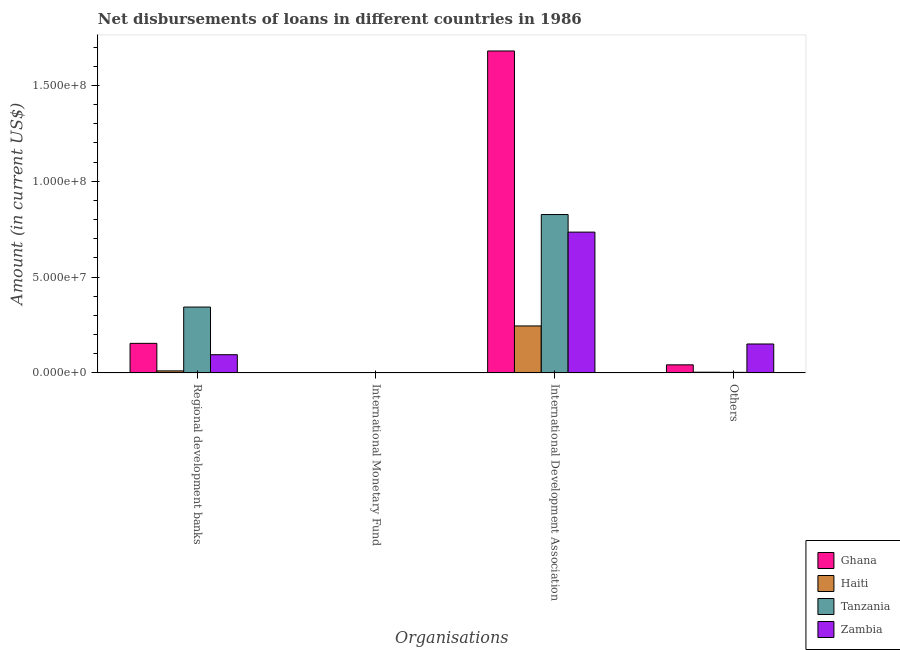How many different coloured bars are there?
Your answer should be compact. 4. Are the number of bars on each tick of the X-axis equal?
Offer a terse response. No. What is the label of the 1st group of bars from the left?
Provide a short and direct response. Regional development banks. What is the amount of loan disimbursed by other organisations in Tanzania?
Keep it short and to the point. 2.67e+05. Across all countries, what is the maximum amount of loan disimbursed by other organisations?
Keep it short and to the point. 1.51e+07. Across all countries, what is the minimum amount of loan disimbursed by other organisations?
Your answer should be compact. 2.67e+05. What is the total amount of loan disimbursed by other organisations in the graph?
Make the answer very short. 1.99e+07. What is the difference between the amount of loan disimbursed by other organisations in Haiti and that in Ghana?
Offer a terse response. -3.83e+06. What is the difference between the amount of loan disimbursed by international monetary fund in Haiti and the amount of loan disimbursed by other organisations in Ghana?
Your answer should be very brief. -4.19e+06. What is the average amount of loan disimbursed by regional development banks per country?
Your answer should be very brief. 1.51e+07. What is the difference between the amount of loan disimbursed by international development association and amount of loan disimbursed by other organisations in Zambia?
Give a very brief answer. 5.84e+07. What is the ratio of the amount of loan disimbursed by international development association in Zambia to that in Tanzania?
Your answer should be compact. 0.89. What is the difference between the highest and the second highest amount of loan disimbursed by international development association?
Offer a very short reply. 8.53e+07. What is the difference between the highest and the lowest amount of loan disimbursed by other organisations?
Provide a short and direct response. 1.48e+07. What is the difference between two consecutive major ticks on the Y-axis?
Offer a terse response. 5.00e+07. Are the values on the major ticks of Y-axis written in scientific E-notation?
Ensure brevity in your answer.  Yes. Does the graph contain grids?
Your response must be concise. No. Where does the legend appear in the graph?
Give a very brief answer. Bottom right. What is the title of the graph?
Give a very brief answer. Net disbursements of loans in different countries in 1986. What is the label or title of the X-axis?
Provide a short and direct response. Organisations. What is the Amount (in current US$) of Ghana in Regional development banks?
Your answer should be compact. 1.54e+07. What is the Amount (in current US$) of Haiti in Regional development banks?
Your answer should be very brief. 1.03e+06. What is the Amount (in current US$) of Tanzania in Regional development banks?
Provide a succinct answer. 3.43e+07. What is the Amount (in current US$) of Zambia in Regional development banks?
Keep it short and to the point. 9.48e+06. What is the Amount (in current US$) of Ghana in International Development Association?
Offer a very short reply. 1.68e+08. What is the Amount (in current US$) of Haiti in International Development Association?
Your response must be concise. 2.45e+07. What is the Amount (in current US$) of Tanzania in International Development Association?
Make the answer very short. 8.26e+07. What is the Amount (in current US$) in Zambia in International Development Association?
Give a very brief answer. 7.34e+07. What is the Amount (in current US$) in Ghana in Others?
Offer a very short reply. 4.19e+06. What is the Amount (in current US$) in Haiti in Others?
Your answer should be compact. 3.60e+05. What is the Amount (in current US$) in Tanzania in Others?
Keep it short and to the point. 2.67e+05. What is the Amount (in current US$) of Zambia in Others?
Your answer should be compact. 1.51e+07. Across all Organisations, what is the maximum Amount (in current US$) in Ghana?
Provide a short and direct response. 1.68e+08. Across all Organisations, what is the maximum Amount (in current US$) in Haiti?
Provide a succinct answer. 2.45e+07. Across all Organisations, what is the maximum Amount (in current US$) of Tanzania?
Offer a terse response. 8.26e+07. Across all Organisations, what is the maximum Amount (in current US$) in Zambia?
Make the answer very short. 7.34e+07. Across all Organisations, what is the minimum Amount (in current US$) in Haiti?
Your response must be concise. 0. What is the total Amount (in current US$) of Ghana in the graph?
Offer a terse response. 1.88e+08. What is the total Amount (in current US$) of Haiti in the graph?
Provide a short and direct response. 2.59e+07. What is the total Amount (in current US$) in Tanzania in the graph?
Your answer should be very brief. 1.17e+08. What is the total Amount (in current US$) of Zambia in the graph?
Provide a short and direct response. 9.80e+07. What is the difference between the Amount (in current US$) of Ghana in Regional development banks and that in International Development Association?
Your answer should be compact. -1.53e+08. What is the difference between the Amount (in current US$) of Haiti in Regional development banks and that in International Development Association?
Your answer should be very brief. -2.35e+07. What is the difference between the Amount (in current US$) of Tanzania in Regional development banks and that in International Development Association?
Provide a short and direct response. -4.83e+07. What is the difference between the Amount (in current US$) in Zambia in Regional development banks and that in International Development Association?
Offer a very short reply. -6.40e+07. What is the difference between the Amount (in current US$) in Ghana in Regional development banks and that in Others?
Make the answer very short. 1.12e+07. What is the difference between the Amount (in current US$) in Haiti in Regional development banks and that in Others?
Ensure brevity in your answer.  6.70e+05. What is the difference between the Amount (in current US$) in Tanzania in Regional development banks and that in Others?
Provide a succinct answer. 3.41e+07. What is the difference between the Amount (in current US$) in Zambia in Regional development banks and that in Others?
Make the answer very short. -5.59e+06. What is the difference between the Amount (in current US$) of Ghana in International Development Association and that in Others?
Your answer should be compact. 1.64e+08. What is the difference between the Amount (in current US$) in Haiti in International Development Association and that in Others?
Your answer should be compact. 2.41e+07. What is the difference between the Amount (in current US$) of Tanzania in International Development Association and that in Others?
Provide a succinct answer. 8.23e+07. What is the difference between the Amount (in current US$) in Zambia in International Development Association and that in Others?
Keep it short and to the point. 5.84e+07. What is the difference between the Amount (in current US$) in Ghana in Regional development banks and the Amount (in current US$) in Haiti in International Development Association?
Provide a succinct answer. -9.08e+06. What is the difference between the Amount (in current US$) of Ghana in Regional development banks and the Amount (in current US$) of Tanzania in International Development Association?
Ensure brevity in your answer.  -6.72e+07. What is the difference between the Amount (in current US$) in Ghana in Regional development banks and the Amount (in current US$) in Zambia in International Development Association?
Your answer should be compact. -5.80e+07. What is the difference between the Amount (in current US$) of Haiti in Regional development banks and the Amount (in current US$) of Tanzania in International Development Association?
Keep it short and to the point. -8.16e+07. What is the difference between the Amount (in current US$) of Haiti in Regional development banks and the Amount (in current US$) of Zambia in International Development Association?
Your answer should be very brief. -7.24e+07. What is the difference between the Amount (in current US$) in Tanzania in Regional development banks and the Amount (in current US$) in Zambia in International Development Association?
Keep it short and to the point. -3.91e+07. What is the difference between the Amount (in current US$) in Ghana in Regional development banks and the Amount (in current US$) in Haiti in Others?
Your answer should be very brief. 1.50e+07. What is the difference between the Amount (in current US$) in Ghana in Regional development banks and the Amount (in current US$) in Tanzania in Others?
Offer a terse response. 1.51e+07. What is the difference between the Amount (in current US$) in Ghana in Regional development banks and the Amount (in current US$) in Zambia in Others?
Your answer should be compact. 3.32e+05. What is the difference between the Amount (in current US$) in Haiti in Regional development banks and the Amount (in current US$) in Tanzania in Others?
Keep it short and to the point. 7.63e+05. What is the difference between the Amount (in current US$) of Haiti in Regional development banks and the Amount (in current US$) of Zambia in Others?
Your answer should be compact. -1.40e+07. What is the difference between the Amount (in current US$) in Tanzania in Regional development banks and the Amount (in current US$) in Zambia in Others?
Ensure brevity in your answer.  1.93e+07. What is the difference between the Amount (in current US$) of Ghana in International Development Association and the Amount (in current US$) of Haiti in Others?
Offer a terse response. 1.68e+08. What is the difference between the Amount (in current US$) in Ghana in International Development Association and the Amount (in current US$) in Tanzania in Others?
Provide a short and direct response. 1.68e+08. What is the difference between the Amount (in current US$) in Ghana in International Development Association and the Amount (in current US$) in Zambia in Others?
Ensure brevity in your answer.  1.53e+08. What is the difference between the Amount (in current US$) of Haiti in International Development Association and the Amount (in current US$) of Tanzania in Others?
Your answer should be compact. 2.42e+07. What is the difference between the Amount (in current US$) of Haiti in International Development Association and the Amount (in current US$) of Zambia in Others?
Your response must be concise. 9.42e+06. What is the difference between the Amount (in current US$) in Tanzania in International Development Association and the Amount (in current US$) in Zambia in Others?
Your answer should be very brief. 6.75e+07. What is the average Amount (in current US$) of Ghana per Organisations?
Offer a very short reply. 4.69e+07. What is the average Amount (in current US$) in Haiti per Organisations?
Ensure brevity in your answer.  6.47e+06. What is the average Amount (in current US$) of Tanzania per Organisations?
Ensure brevity in your answer.  2.93e+07. What is the average Amount (in current US$) of Zambia per Organisations?
Offer a very short reply. 2.45e+07. What is the difference between the Amount (in current US$) of Ghana and Amount (in current US$) of Haiti in Regional development banks?
Your answer should be compact. 1.44e+07. What is the difference between the Amount (in current US$) of Ghana and Amount (in current US$) of Tanzania in Regional development banks?
Keep it short and to the point. -1.89e+07. What is the difference between the Amount (in current US$) of Ghana and Amount (in current US$) of Zambia in Regional development banks?
Offer a very short reply. 5.92e+06. What is the difference between the Amount (in current US$) of Haiti and Amount (in current US$) of Tanzania in Regional development banks?
Your response must be concise. -3.33e+07. What is the difference between the Amount (in current US$) of Haiti and Amount (in current US$) of Zambia in Regional development banks?
Provide a succinct answer. -8.45e+06. What is the difference between the Amount (in current US$) in Tanzania and Amount (in current US$) in Zambia in Regional development banks?
Keep it short and to the point. 2.49e+07. What is the difference between the Amount (in current US$) in Ghana and Amount (in current US$) in Haiti in International Development Association?
Offer a very short reply. 1.43e+08. What is the difference between the Amount (in current US$) of Ghana and Amount (in current US$) of Tanzania in International Development Association?
Ensure brevity in your answer.  8.53e+07. What is the difference between the Amount (in current US$) of Ghana and Amount (in current US$) of Zambia in International Development Association?
Offer a very short reply. 9.45e+07. What is the difference between the Amount (in current US$) in Haiti and Amount (in current US$) in Tanzania in International Development Association?
Ensure brevity in your answer.  -5.81e+07. What is the difference between the Amount (in current US$) of Haiti and Amount (in current US$) of Zambia in International Development Association?
Keep it short and to the point. -4.90e+07. What is the difference between the Amount (in current US$) of Tanzania and Amount (in current US$) of Zambia in International Development Association?
Your answer should be very brief. 9.16e+06. What is the difference between the Amount (in current US$) of Ghana and Amount (in current US$) of Haiti in Others?
Your answer should be very brief. 3.83e+06. What is the difference between the Amount (in current US$) of Ghana and Amount (in current US$) of Tanzania in Others?
Your answer should be compact. 3.92e+06. What is the difference between the Amount (in current US$) in Ghana and Amount (in current US$) in Zambia in Others?
Keep it short and to the point. -1.09e+07. What is the difference between the Amount (in current US$) of Haiti and Amount (in current US$) of Tanzania in Others?
Your response must be concise. 9.30e+04. What is the difference between the Amount (in current US$) in Haiti and Amount (in current US$) in Zambia in Others?
Provide a succinct answer. -1.47e+07. What is the difference between the Amount (in current US$) of Tanzania and Amount (in current US$) of Zambia in Others?
Provide a succinct answer. -1.48e+07. What is the ratio of the Amount (in current US$) in Ghana in Regional development banks to that in International Development Association?
Provide a succinct answer. 0.09. What is the ratio of the Amount (in current US$) of Haiti in Regional development banks to that in International Development Association?
Provide a short and direct response. 0.04. What is the ratio of the Amount (in current US$) in Tanzania in Regional development banks to that in International Development Association?
Make the answer very short. 0.42. What is the ratio of the Amount (in current US$) of Zambia in Regional development banks to that in International Development Association?
Your answer should be very brief. 0.13. What is the ratio of the Amount (in current US$) in Ghana in Regional development banks to that in Others?
Your answer should be very brief. 3.67. What is the ratio of the Amount (in current US$) of Haiti in Regional development banks to that in Others?
Your answer should be very brief. 2.86. What is the ratio of the Amount (in current US$) in Tanzania in Regional development banks to that in Others?
Provide a succinct answer. 128.6. What is the ratio of the Amount (in current US$) in Zambia in Regional development banks to that in Others?
Your answer should be compact. 0.63. What is the ratio of the Amount (in current US$) of Ghana in International Development Association to that in Others?
Provide a succinct answer. 40.06. What is the ratio of the Amount (in current US$) in Haiti in International Development Association to that in Others?
Your response must be concise. 68.01. What is the ratio of the Amount (in current US$) in Tanzania in International Development Association to that in Others?
Your answer should be very brief. 309.38. What is the ratio of the Amount (in current US$) of Zambia in International Development Association to that in Others?
Give a very brief answer. 4.87. What is the difference between the highest and the second highest Amount (in current US$) in Ghana?
Your answer should be compact. 1.53e+08. What is the difference between the highest and the second highest Amount (in current US$) in Haiti?
Provide a succinct answer. 2.35e+07. What is the difference between the highest and the second highest Amount (in current US$) of Tanzania?
Provide a succinct answer. 4.83e+07. What is the difference between the highest and the second highest Amount (in current US$) in Zambia?
Provide a succinct answer. 5.84e+07. What is the difference between the highest and the lowest Amount (in current US$) of Ghana?
Offer a terse response. 1.68e+08. What is the difference between the highest and the lowest Amount (in current US$) in Haiti?
Your answer should be compact. 2.45e+07. What is the difference between the highest and the lowest Amount (in current US$) in Tanzania?
Your answer should be compact. 8.26e+07. What is the difference between the highest and the lowest Amount (in current US$) in Zambia?
Provide a succinct answer. 7.34e+07. 